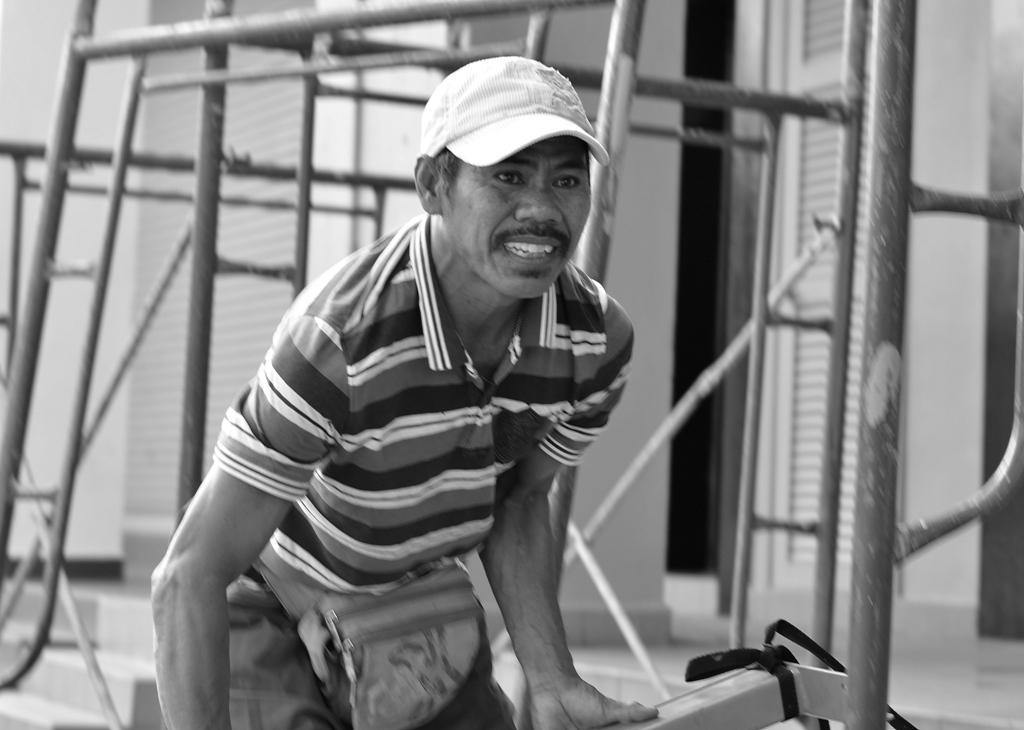What is the main subject of the image? There is a man in the image. What is the man doing in the image? The man is standing in the image. What is the man holding in the image? The man is holding an object in the image. What type of headwear is the man wearing in the image? The man is wearing a hat in the image. What type of fear can be seen on the man's face in the image? There is no indication of fear on the man's face in the image. 